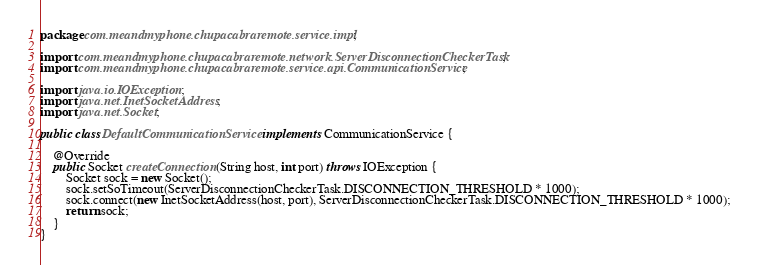<code> <loc_0><loc_0><loc_500><loc_500><_Java_>package com.meandmyphone.chupacabraremote.service.impl;

import com.meandmyphone.chupacabraremote.network.ServerDisconnectionCheckerTask;
import com.meandmyphone.chupacabraremote.service.api.CommunicationService;

import java.io.IOException;
import java.net.InetSocketAddress;
import java.net.Socket;

public class DefaultCommunicationService implements CommunicationService {

    @Override
    public Socket createConnection(String host, int port) throws IOException {
        Socket sock = new Socket();
        sock.setSoTimeout(ServerDisconnectionCheckerTask.DISCONNECTION_THRESHOLD * 1000);
        sock.connect(new InetSocketAddress(host, port), ServerDisconnectionCheckerTask.DISCONNECTION_THRESHOLD * 1000);
        return sock;
    }
}
</code> 